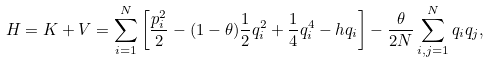Convert formula to latex. <formula><loc_0><loc_0><loc_500><loc_500>H = K + V = \sum _ { i = 1 } ^ { N } \left [ \frac { p _ { i } ^ { 2 } } { 2 } - ( 1 - \theta ) \frac { 1 } { 2 } q _ { i } ^ { 2 } + \frac { 1 } { 4 } q _ { i } ^ { 4 } - h q _ { i } \right ] - \frac { \theta } { 2 N } \sum _ { i , j = 1 } ^ { N } q _ { i } q _ { j } ,</formula> 